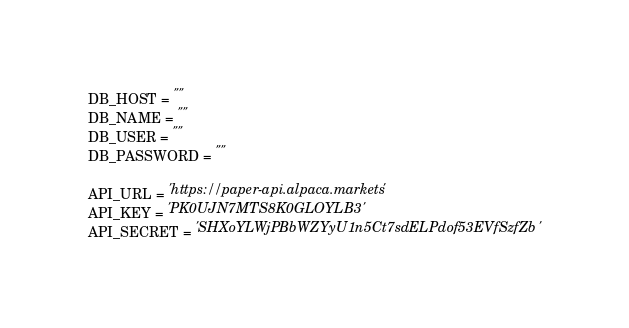Convert code to text. <code><loc_0><loc_0><loc_500><loc_500><_Python_>DB_HOST = ""
DB_NAME = ""
DB_USER = ""
DB_PASSWORD = ""

API_URL = 'https://paper-api.alpaca.markets'
API_KEY = 'PK0UJN7MTS8K0GLOYLB3'
API_SECRET = 'SHXoYLWjPBbWZYyU1n5Ct7sdELPdof53EVfSzfZb'</code> 